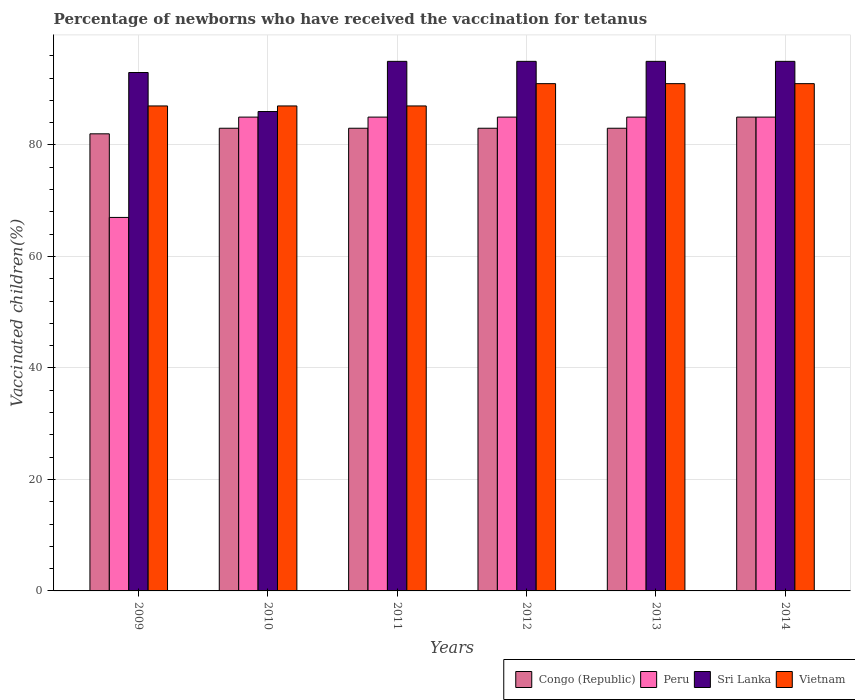How many groups of bars are there?
Give a very brief answer. 6. Are the number of bars per tick equal to the number of legend labels?
Offer a terse response. Yes. Are the number of bars on each tick of the X-axis equal?
Provide a short and direct response. Yes. How many bars are there on the 1st tick from the left?
Your answer should be compact. 4. In how many cases, is the number of bars for a given year not equal to the number of legend labels?
Offer a terse response. 0. What is the percentage of vaccinated children in Sri Lanka in 2010?
Your response must be concise. 86. Across all years, what is the minimum percentage of vaccinated children in Congo (Republic)?
Provide a succinct answer. 82. What is the total percentage of vaccinated children in Peru in the graph?
Offer a very short reply. 492. What is the difference between the percentage of vaccinated children in Peru in 2012 and that in 2014?
Make the answer very short. 0. What is the difference between the percentage of vaccinated children in Peru in 2011 and the percentage of vaccinated children in Congo (Republic) in 2012?
Your answer should be compact. 2. What is the average percentage of vaccinated children in Vietnam per year?
Your answer should be very brief. 89. In the year 2010, what is the difference between the percentage of vaccinated children in Peru and percentage of vaccinated children in Vietnam?
Give a very brief answer. -2. What is the ratio of the percentage of vaccinated children in Peru in 2010 to that in 2013?
Provide a short and direct response. 1. Is the difference between the percentage of vaccinated children in Peru in 2009 and 2012 greater than the difference between the percentage of vaccinated children in Vietnam in 2009 and 2012?
Your response must be concise. No. What is the difference between the highest and the lowest percentage of vaccinated children in Sri Lanka?
Offer a terse response. 9. Is the sum of the percentage of vaccinated children in Congo (Republic) in 2010 and 2013 greater than the maximum percentage of vaccinated children in Vietnam across all years?
Give a very brief answer. Yes. Is it the case that in every year, the sum of the percentage of vaccinated children in Congo (Republic) and percentage of vaccinated children in Vietnam is greater than the sum of percentage of vaccinated children in Peru and percentage of vaccinated children in Sri Lanka?
Make the answer very short. No. What does the 1st bar from the left in 2012 represents?
Your answer should be very brief. Congo (Republic). What does the 4th bar from the right in 2009 represents?
Keep it short and to the point. Congo (Republic). Is it the case that in every year, the sum of the percentage of vaccinated children in Sri Lanka and percentage of vaccinated children in Congo (Republic) is greater than the percentage of vaccinated children in Peru?
Give a very brief answer. Yes. How many bars are there?
Provide a short and direct response. 24. How many years are there in the graph?
Your response must be concise. 6. What is the difference between two consecutive major ticks on the Y-axis?
Offer a very short reply. 20. Are the values on the major ticks of Y-axis written in scientific E-notation?
Provide a succinct answer. No. Does the graph contain grids?
Offer a terse response. Yes. Where does the legend appear in the graph?
Keep it short and to the point. Bottom right. How many legend labels are there?
Keep it short and to the point. 4. How are the legend labels stacked?
Your response must be concise. Horizontal. What is the title of the graph?
Offer a very short reply. Percentage of newborns who have received the vaccination for tetanus. Does "Turkmenistan" appear as one of the legend labels in the graph?
Your answer should be compact. No. What is the label or title of the Y-axis?
Your answer should be compact. Vaccinated children(%). What is the Vaccinated children(%) of Peru in 2009?
Keep it short and to the point. 67. What is the Vaccinated children(%) of Sri Lanka in 2009?
Offer a terse response. 93. What is the Vaccinated children(%) of Peru in 2010?
Provide a succinct answer. 85. What is the Vaccinated children(%) of Sri Lanka in 2010?
Your answer should be very brief. 86. What is the Vaccinated children(%) in Vietnam in 2010?
Provide a short and direct response. 87. What is the Vaccinated children(%) in Peru in 2011?
Provide a short and direct response. 85. What is the Vaccinated children(%) of Sri Lanka in 2011?
Offer a terse response. 95. What is the Vaccinated children(%) in Peru in 2012?
Ensure brevity in your answer.  85. What is the Vaccinated children(%) of Sri Lanka in 2012?
Provide a short and direct response. 95. What is the Vaccinated children(%) in Vietnam in 2012?
Offer a very short reply. 91. What is the Vaccinated children(%) in Peru in 2013?
Your answer should be compact. 85. What is the Vaccinated children(%) of Vietnam in 2013?
Offer a terse response. 91. What is the Vaccinated children(%) of Congo (Republic) in 2014?
Your response must be concise. 85. What is the Vaccinated children(%) of Peru in 2014?
Ensure brevity in your answer.  85. What is the Vaccinated children(%) of Vietnam in 2014?
Provide a short and direct response. 91. Across all years, what is the maximum Vaccinated children(%) of Congo (Republic)?
Make the answer very short. 85. Across all years, what is the maximum Vaccinated children(%) in Vietnam?
Ensure brevity in your answer.  91. What is the total Vaccinated children(%) in Congo (Republic) in the graph?
Offer a terse response. 499. What is the total Vaccinated children(%) in Peru in the graph?
Ensure brevity in your answer.  492. What is the total Vaccinated children(%) of Sri Lanka in the graph?
Offer a very short reply. 559. What is the total Vaccinated children(%) in Vietnam in the graph?
Offer a very short reply. 534. What is the difference between the Vaccinated children(%) in Congo (Republic) in 2009 and that in 2010?
Make the answer very short. -1. What is the difference between the Vaccinated children(%) in Congo (Republic) in 2009 and that in 2011?
Give a very brief answer. -1. What is the difference between the Vaccinated children(%) in Peru in 2009 and that in 2011?
Ensure brevity in your answer.  -18. What is the difference between the Vaccinated children(%) in Sri Lanka in 2009 and that in 2011?
Your answer should be compact. -2. What is the difference between the Vaccinated children(%) of Vietnam in 2009 and that in 2011?
Provide a short and direct response. 0. What is the difference between the Vaccinated children(%) in Vietnam in 2009 and that in 2012?
Offer a very short reply. -4. What is the difference between the Vaccinated children(%) of Congo (Republic) in 2009 and that in 2013?
Ensure brevity in your answer.  -1. What is the difference between the Vaccinated children(%) of Peru in 2009 and that in 2013?
Offer a terse response. -18. What is the difference between the Vaccinated children(%) in Peru in 2009 and that in 2014?
Your response must be concise. -18. What is the difference between the Vaccinated children(%) in Sri Lanka in 2009 and that in 2014?
Your answer should be very brief. -2. What is the difference between the Vaccinated children(%) in Peru in 2010 and that in 2011?
Offer a terse response. 0. What is the difference between the Vaccinated children(%) in Sri Lanka in 2010 and that in 2011?
Make the answer very short. -9. What is the difference between the Vaccinated children(%) of Vietnam in 2010 and that in 2011?
Provide a succinct answer. 0. What is the difference between the Vaccinated children(%) of Peru in 2010 and that in 2012?
Keep it short and to the point. 0. What is the difference between the Vaccinated children(%) of Peru in 2010 and that in 2013?
Provide a succinct answer. 0. What is the difference between the Vaccinated children(%) of Congo (Republic) in 2010 and that in 2014?
Your answer should be compact. -2. What is the difference between the Vaccinated children(%) in Peru in 2011 and that in 2012?
Your answer should be compact. 0. What is the difference between the Vaccinated children(%) of Sri Lanka in 2011 and that in 2012?
Provide a short and direct response. 0. What is the difference between the Vaccinated children(%) of Congo (Republic) in 2011 and that in 2014?
Give a very brief answer. -2. What is the difference between the Vaccinated children(%) of Congo (Republic) in 2012 and that in 2013?
Ensure brevity in your answer.  0. What is the difference between the Vaccinated children(%) of Peru in 2012 and that in 2013?
Ensure brevity in your answer.  0. What is the difference between the Vaccinated children(%) in Sri Lanka in 2012 and that in 2014?
Your answer should be compact. 0. What is the difference between the Vaccinated children(%) in Vietnam in 2013 and that in 2014?
Give a very brief answer. 0. What is the difference between the Vaccinated children(%) in Sri Lanka in 2009 and the Vaccinated children(%) in Vietnam in 2010?
Your response must be concise. 6. What is the difference between the Vaccinated children(%) in Congo (Republic) in 2009 and the Vaccinated children(%) in Peru in 2011?
Keep it short and to the point. -3. What is the difference between the Vaccinated children(%) of Congo (Republic) in 2009 and the Vaccinated children(%) of Sri Lanka in 2011?
Ensure brevity in your answer.  -13. What is the difference between the Vaccinated children(%) in Peru in 2009 and the Vaccinated children(%) in Sri Lanka in 2012?
Offer a terse response. -28. What is the difference between the Vaccinated children(%) of Peru in 2009 and the Vaccinated children(%) of Vietnam in 2012?
Ensure brevity in your answer.  -24. What is the difference between the Vaccinated children(%) in Congo (Republic) in 2009 and the Vaccinated children(%) in Peru in 2013?
Give a very brief answer. -3. What is the difference between the Vaccinated children(%) in Congo (Republic) in 2009 and the Vaccinated children(%) in Sri Lanka in 2013?
Provide a short and direct response. -13. What is the difference between the Vaccinated children(%) of Congo (Republic) in 2009 and the Vaccinated children(%) of Peru in 2014?
Your answer should be very brief. -3. What is the difference between the Vaccinated children(%) in Peru in 2009 and the Vaccinated children(%) in Sri Lanka in 2014?
Your answer should be very brief. -28. What is the difference between the Vaccinated children(%) of Peru in 2009 and the Vaccinated children(%) of Vietnam in 2014?
Ensure brevity in your answer.  -24. What is the difference between the Vaccinated children(%) in Sri Lanka in 2009 and the Vaccinated children(%) in Vietnam in 2014?
Offer a terse response. 2. What is the difference between the Vaccinated children(%) in Peru in 2010 and the Vaccinated children(%) in Sri Lanka in 2011?
Provide a short and direct response. -10. What is the difference between the Vaccinated children(%) in Peru in 2010 and the Vaccinated children(%) in Vietnam in 2011?
Ensure brevity in your answer.  -2. What is the difference between the Vaccinated children(%) in Sri Lanka in 2010 and the Vaccinated children(%) in Vietnam in 2011?
Give a very brief answer. -1. What is the difference between the Vaccinated children(%) in Congo (Republic) in 2010 and the Vaccinated children(%) in Peru in 2012?
Offer a terse response. -2. What is the difference between the Vaccinated children(%) in Congo (Republic) in 2010 and the Vaccinated children(%) in Sri Lanka in 2012?
Offer a very short reply. -12. What is the difference between the Vaccinated children(%) in Congo (Republic) in 2010 and the Vaccinated children(%) in Vietnam in 2012?
Keep it short and to the point. -8. What is the difference between the Vaccinated children(%) of Peru in 2010 and the Vaccinated children(%) of Vietnam in 2012?
Keep it short and to the point. -6. What is the difference between the Vaccinated children(%) of Sri Lanka in 2010 and the Vaccinated children(%) of Vietnam in 2012?
Keep it short and to the point. -5. What is the difference between the Vaccinated children(%) in Congo (Republic) in 2010 and the Vaccinated children(%) in Peru in 2013?
Keep it short and to the point. -2. What is the difference between the Vaccinated children(%) of Sri Lanka in 2010 and the Vaccinated children(%) of Vietnam in 2013?
Your answer should be compact. -5. What is the difference between the Vaccinated children(%) in Congo (Republic) in 2010 and the Vaccinated children(%) in Peru in 2014?
Provide a short and direct response. -2. What is the difference between the Vaccinated children(%) of Congo (Republic) in 2010 and the Vaccinated children(%) of Vietnam in 2014?
Offer a very short reply. -8. What is the difference between the Vaccinated children(%) in Peru in 2010 and the Vaccinated children(%) in Sri Lanka in 2014?
Ensure brevity in your answer.  -10. What is the difference between the Vaccinated children(%) in Peru in 2010 and the Vaccinated children(%) in Vietnam in 2014?
Make the answer very short. -6. What is the difference between the Vaccinated children(%) in Sri Lanka in 2010 and the Vaccinated children(%) in Vietnam in 2014?
Provide a short and direct response. -5. What is the difference between the Vaccinated children(%) in Congo (Republic) in 2011 and the Vaccinated children(%) in Peru in 2012?
Ensure brevity in your answer.  -2. What is the difference between the Vaccinated children(%) in Congo (Republic) in 2011 and the Vaccinated children(%) in Vietnam in 2012?
Offer a terse response. -8. What is the difference between the Vaccinated children(%) of Peru in 2011 and the Vaccinated children(%) of Sri Lanka in 2012?
Ensure brevity in your answer.  -10. What is the difference between the Vaccinated children(%) in Sri Lanka in 2011 and the Vaccinated children(%) in Vietnam in 2012?
Provide a succinct answer. 4. What is the difference between the Vaccinated children(%) of Congo (Republic) in 2011 and the Vaccinated children(%) of Peru in 2013?
Give a very brief answer. -2. What is the difference between the Vaccinated children(%) of Congo (Republic) in 2011 and the Vaccinated children(%) of Sri Lanka in 2013?
Offer a terse response. -12. What is the difference between the Vaccinated children(%) of Peru in 2011 and the Vaccinated children(%) of Sri Lanka in 2013?
Provide a short and direct response. -10. What is the difference between the Vaccinated children(%) in Sri Lanka in 2011 and the Vaccinated children(%) in Vietnam in 2013?
Ensure brevity in your answer.  4. What is the difference between the Vaccinated children(%) in Congo (Republic) in 2011 and the Vaccinated children(%) in Peru in 2014?
Offer a very short reply. -2. What is the difference between the Vaccinated children(%) in Congo (Republic) in 2011 and the Vaccinated children(%) in Vietnam in 2014?
Provide a succinct answer. -8. What is the difference between the Vaccinated children(%) of Peru in 2011 and the Vaccinated children(%) of Vietnam in 2014?
Offer a very short reply. -6. What is the difference between the Vaccinated children(%) in Sri Lanka in 2011 and the Vaccinated children(%) in Vietnam in 2014?
Provide a succinct answer. 4. What is the difference between the Vaccinated children(%) of Congo (Republic) in 2012 and the Vaccinated children(%) of Peru in 2013?
Provide a succinct answer. -2. What is the difference between the Vaccinated children(%) of Congo (Republic) in 2012 and the Vaccinated children(%) of Vietnam in 2013?
Your answer should be very brief. -8. What is the difference between the Vaccinated children(%) of Peru in 2012 and the Vaccinated children(%) of Vietnam in 2013?
Keep it short and to the point. -6. What is the difference between the Vaccinated children(%) of Peru in 2012 and the Vaccinated children(%) of Vietnam in 2014?
Ensure brevity in your answer.  -6. What is the difference between the Vaccinated children(%) of Congo (Republic) in 2013 and the Vaccinated children(%) of Peru in 2014?
Your answer should be very brief. -2. What is the difference between the Vaccinated children(%) in Peru in 2013 and the Vaccinated children(%) in Sri Lanka in 2014?
Keep it short and to the point. -10. What is the difference between the Vaccinated children(%) of Peru in 2013 and the Vaccinated children(%) of Vietnam in 2014?
Your response must be concise. -6. What is the difference between the Vaccinated children(%) in Sri Lanka in 2013 and the Vaccinated children(%) in Vietnam in 2014?
Keep it short and to the point. 4. What is the average Vaccinated children(%) in Congo (Republic) per year?
Provide a short and direct response. 83.17. What is the average Vaccinated children(%) in Peru per year?
Keep it short and to the point. 82. What is the average Vaccinated children(%) in Sri Lanka per year?
Keep it short and to the point. 93.17. What is the average Vaccinated children(%) of Vietnam per year?
Provide a short and direct response. 89. In the year 2009, what is the difference between the Vaccinated children(%) of Peru and Vaccinated children(%) of Sri Lanka?
Provide a short and direct response. -26. In the year 2009, what is the difference between the Vaccinated children(%) of Sri Lanka and Vaccinated children(%) of Vietnam?
Give a very brief answer. 6. In the year 2010, what is the difference between the Vaccinated children(%) of Congo (Republic) and Vaccinated children(%) of Sri Lanka?
Offer a very short reply. -3. In the year 2010, what is the difference between the Vaccinated children(%) of Congo (Republic) and Vaccinated children(%) of Vietnam?
Your response must be concise. -4. In the year 2010, what is the difference between the Vaccinated children(%) in Peru and Vaccinated children(%) in Sri Lanka?
Your answer should be very brief. -1. In the year 2010, what is the difference between the Vaccinated children(%) in Peru and Vaccinated children(%) in Vietnam?
Provide a short and direct response. -2. In the year 2010, what is the difference between the Vaccinated children(%) of Sri Lanka and Vaccinated children(%) of Vietnam?
Offer a terse response. -1. In the year 2011, what is the difference between the Vaccinated children(%) of Congo (Republic) and Vaccinated children(%) of Peru?
Ensure brevity in your answer.  -2. In the year 2011, what is the difference between the Vaccinated children(%) of Peru and Vaccinated children(%) of Sri Lanka?
Offer a very short reply. -10. In the year 2011, what is the difference between the Vaccinated children(%) of Sri Lanka and Vaccinated children(%) of Vietnam?
Provide a short and direct response. 8. In the year 2012, what is the difference between the Vaccinated children(%) in Congo (Republic) and Vaccinated children(%) in Peru?
Your answer should be compact. -2. In the year 2012, what is the difference between the Vaccinated children(%) of Congo (Republic) and Vaccinated children(%) of Sri Lanka?
Make the answer very short. -12. In the year 2012, what is the difference between the Vaccinated children(%) of Peru and Vaccinated children(%) of Sri Lanka?
Ensure brevity in your answer.  -10. In the year 2013, what is the difference between the Vaccinated children(%) in Congo (Republic) and Vaccinated children(%) in Peru?
Offer a very short reply. -2. In the year 2013, what is the difference between the Vaccinated children(%) in Congo (Republic) and Vaccinated children(%) in Vietnam?
Offer a terse response. -8. In the year 2013, what is the difference between the Vaccinated children(%) in Peru and Vaccinated children(%) in Sri Lanka?
Offer a very short reply. -10. In the year 2013, what is the difference between the Vaccinated children(%) in Peru and Vaccinated children(%) in Vietnam?
Give a very brief answer. -6. What is the ratio of the Vaccinated children(%) of Peru in 2009 to that in 2010?
Keep it short and to the point. 0.79. What is the ratio of the Vaccinated children(%) of Sri Lanka in 2009 to that in 2010?
Your response must be concise. 1.08. What is the ratio of the Vaccinated children(%) of Congo (Republic) in 2009 to that in 2011?
Give a very brief answer. 0.99. What is the ratio of the Vaccinated children(%) in Peru in 2009 to that in 2011?
Keep it short and to the point. 0.79. What is the ratio of the Vaccinated children(%) in Sri Lanka in 2009 to that in 2011?
Provide a succinct answer. 0.98. What is the ratio of the Vaccinated children(%) in Vietnam in 2009 to that in 2011?
Your answer should be compact. 1. What is the ratio of the Vaccinated children(%) in Peru in 2009 to that in 2012?
Your answer should be very brief. 0.79. What is the ratio of the Vaccinated children(%) in Sri Lanka in 2009 to that in 2012?
Ensure brevity in your answer.  0.98. What is the ratio of the Vaccinated children(%) of Vietnam in 2009 to that in 2012?
Ensure brevity in your answer.  0.96. What is the ratio of the Vaccinated children(%) in Peru in 2009 to that in 2013?
Ensure brevity in your answer.  0.79. What is the ratio of the Vaccinated children(%) in Sri Lanka in 2009 to that in 2013?
Your response must be concise. 0.98. What is the ratio of the Vaccinated children(%) of Vietnam in 2009 to that in 2013?
Offer a terse response. 0.96. What is the ratio of the Vaccinated children(%) in Congo (Republic) in 2009 to that in 2014?
Your answer should be very brief. 0.96. What is the ratio of the Vaccinated children(%) in Peru in 2009 to that in 2014?
Your response must be concise. 0.79. What is the ratio of the Vaccinated children(%) in Sri Lanka in 2009 to that in 2014?
Make the answer very short. 0.98. What is the ratio of the Vaccinated children(%) of Vietnam in 2009 to that in 2014?
Give a very brief answer. 0.96. What is the ratio of the Vaccinated children(%) of Sri Lanka in 2010 to that in 2011?
Ensure brevity in your answer.  0.91. What is the ratio of the Vaccinated children(%) of Sri Lanka in 2010 to that in 2012?
Provide a succinct answer. 0.91. What is the ratio of the Vaccinated children(%) of Vietnam in 2010 to that in 2012?
Provide a short and direct response. 0.96. What is the ratio of the Vaccinated children(%) in Sri Lanka in 2010 to that in 2013?
Make the answer very short. 0.91. What is the ratio of the Vaccinated children(%) in Vietnam in 2010 to that in 2013?
Offer a very short reply. 0.96. What is the ratio of the Vaccinated children(%) in Congo (Republic) in 2010 to that in 2014?
Ensure brevity in your answer.  0.98. What is the ratio of the Vaccinated children(%) in Peru in 2010 to that in 2014?
Keep it short and to the point. 1. What is the ratio of the Vaccinated children(%) in Sri Lanka in 2010 to that in 2014?
Ensure brevity in your answer.  0.91. What is the ratio of the Vaccinated children(%) in Vietnam in 2010 to that in 2014?
Your answer should be compact. 0.96. What is the ratio of the Vaccinated children(%) in Vietnam in 2011 to that in 2012?
Your answer should be very brief. 0.96. What is the ratio of the Vaccinated children(%) in Peru in 2011 to that in 2013?
Offer a very short reply. 1. What is the ratio of the Vaccinated children(%) in Sri Lanka in 2011 to that in 2013?
Provide a short and direct response. 1. What is the ratio of the Vaccinated children(%) in Vietnam in 2011 to that in 2013?
Provide a short and direct response. 0.96. What is the ratio of the Vaccinated children(%) in Congo (Republic) in 2011 to that in 2014?
Your answer should be very brief. 0.98. What is the ratio of the Vaccinated children(%) of Peru in 2011 to that in 2014?
Offer a very short reply. 1. What is the ratio of the Vaccinated children(%) in Vietnam in 2011 to that in 2014?
Your answer should be compact. 0.96. What is the ratio of the Vaccinated children(%) of Congo (Republic) in 2012 to that in 2013?
Your response must be concise. 1. What is the ratio of the Vaccinated children(%) in Peru in 2012 to that in 2013?
Provide a succinct answer. 1. What is the ratio of the Vaccinated children(%) in Vietnam in 2012 to that in 2013?
Give a very brief answer. 1. What is the ratio of the Vaccinated children(%) of Congo (Republic) in 2012 to that in 2014?
Your answer should be compact. 0.98. What is the ratio of the Vaccinated children(%) in Peru in 2012 to that in 2014?
Provide a succinct answer. 1. What is the ratio of the Vaccinated children(%) in Sri Lanka in 2012 to that in 2014?
Your response must be concise. 1. What is the ratio of the Vaccinated children(%) of Vietnam in 2012 to that in 2014?
Your answer should be compact. 1. What is the ratio of the Vaccinated children(%) of Congo (Republic) in 2013 to that in 2014?
Ensure brevity in your answer.  0.98. What is the difference between the highest and the second highest Vaccinated children(%) in Congo (Republic)?
Provide a short and direct response. 2. What is the difference between the highest and the second highest Vaccinated children(%) of Sri Lanka?
Ensure brevity in your answer.  0. What is the difference between the highest and the second highest Vaccinated children(%) of Vietnam?
Provide a short and direct response. 0. What is the difference between the highest and the lowest Vaccinated children(%) in Congo (Republic)?
Provide a succinct answer. 3. What is the difference between the highest and the lowest Vaccinated children(%) of Peru?
Ensure brevity in your answer.  18. 